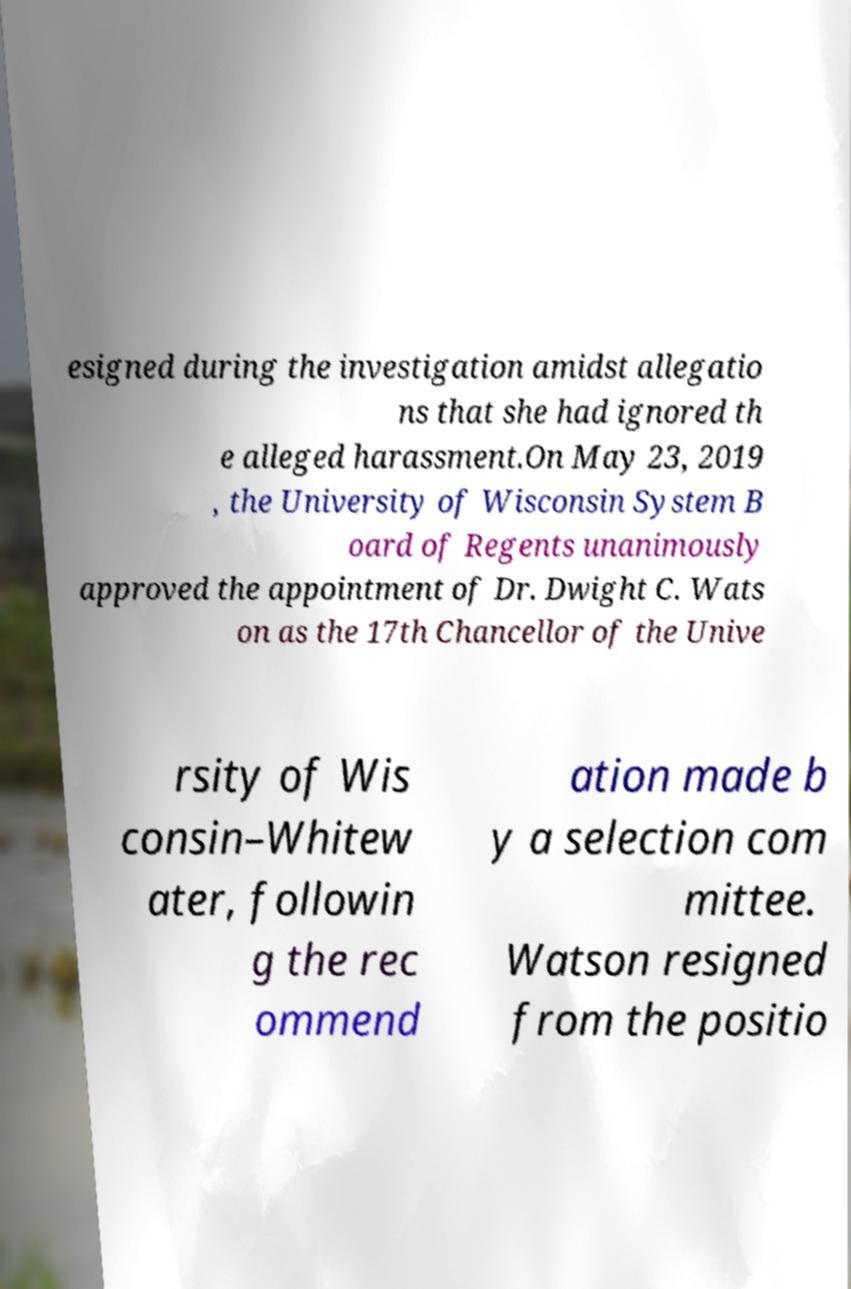I need the written content from this picture converted into text. Can you do that? esigned during the investigation amidst allegatio ns that she had ignored th e alleged harassment.On May 23, 2019 , the University of Wisconsin System B oard of Regents unanimously approved the appointment of Dr. Dwight C. Wats on as the 17th Chancellor of the Unive rsity of Wis consin–Whitew ater, followin g the rec ommend ation made b y a selection com mittee. Watson resigned from the positio 